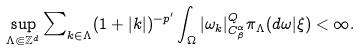Convert formula to latex. <formula><loc_0><loc_0><loc_500><loc_500>\sup _ { \Lambda \Subset \mathbb { Z } ^ { d } } \sum \nolimits _ { k \in \Lambda } ( 1 + | k | ) ^ { - p ^ { \prime } } \int _ { \Omega } | \omega _ { k } | _ { C _ { \beta } ^ { \alpha } } ^ { Q } \pi _ { \Lambda } ( d \omega | \xi ) < \infty .</formula> 